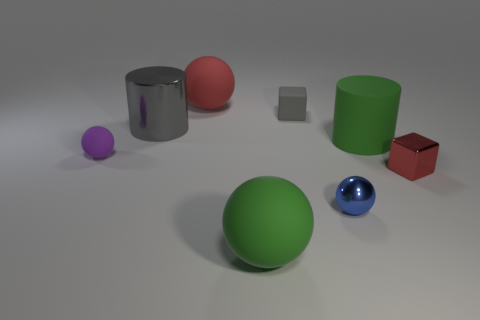Is the number of purple things greater than the number of small green metal spheres? No, the number of purple things, which is one purple sphere, is not greater than the number of small green metal spheres, as there are no small green metal spheres present in the image. 